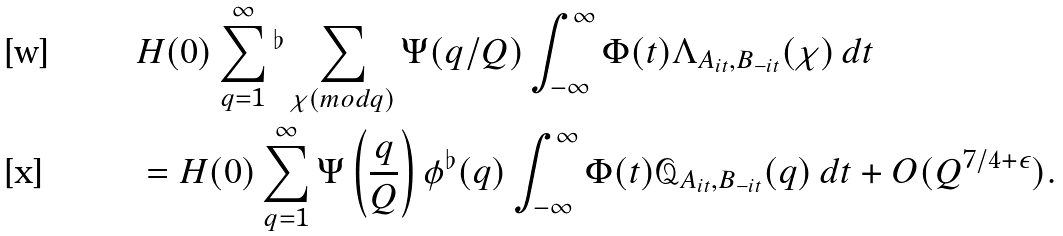Convert formula to latex. <formula><loc_0><loc_0><loc_500><loc_500>& H ( 0 ) \sum _ { q = 1 } ^ { \infty } { ^ { \flat } } \sum _ { \chi ( m o d q ) } \Psi ( q / Q ) \int _ { - \infty } ^ { \infty } \Phi ( t ) \Lambda _ { A _ { i t } , B _ { - i t } } ( \chi ) \, d t \\ & = H ( 0 ) \sum _ { q = 1 } ^ { \infty } \Psi \left ( \frac { q } { Q } \right ) \phi ^ { \flat } ( q ) \int _ { - \infty } ^ { \infty } \Phi ( t ) \mathcal { Q } _ { A _ { i t } , B _ { - i t } } ( q ) \, d t + O ( Q ^ { 7 / 4 + \epsilon } ) .</formula> 